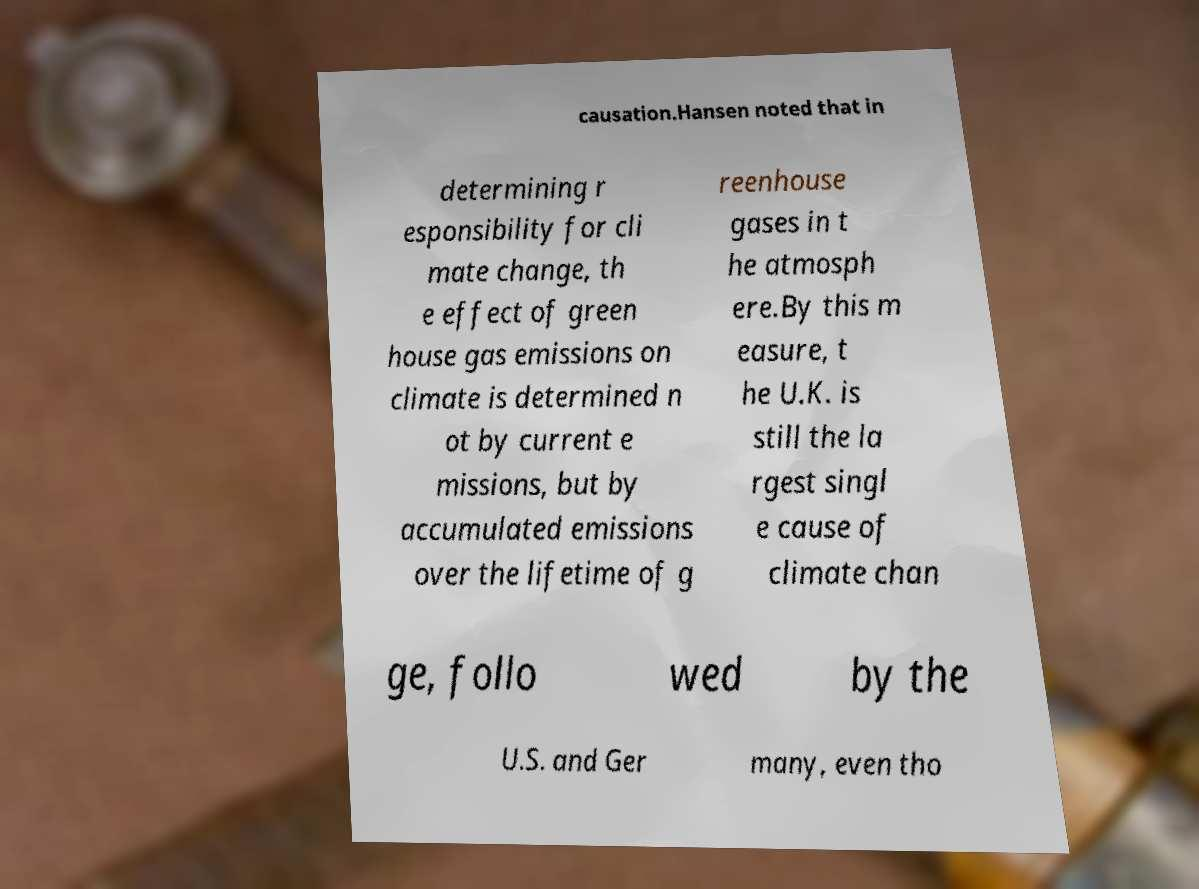There's text embedded in this image that I need extracted. Can you transcribe it verbatim? causation.Hansen noted that in determining r esponsibility for cli mate change, th e effect of green house gas emissions on climate is determined n ot by current e missions, but by accumulated emissions over the lifetime of g reenhouse gases in t he atmosph ere.By this m easure, t he U.K. is still the la rgest singl e cause of climate chan ge, follo wed by the U.S. and Ger many, even tho 